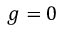<formula> <loc_0><loc_0><loc_500><loc_500>g = 0</formula> 